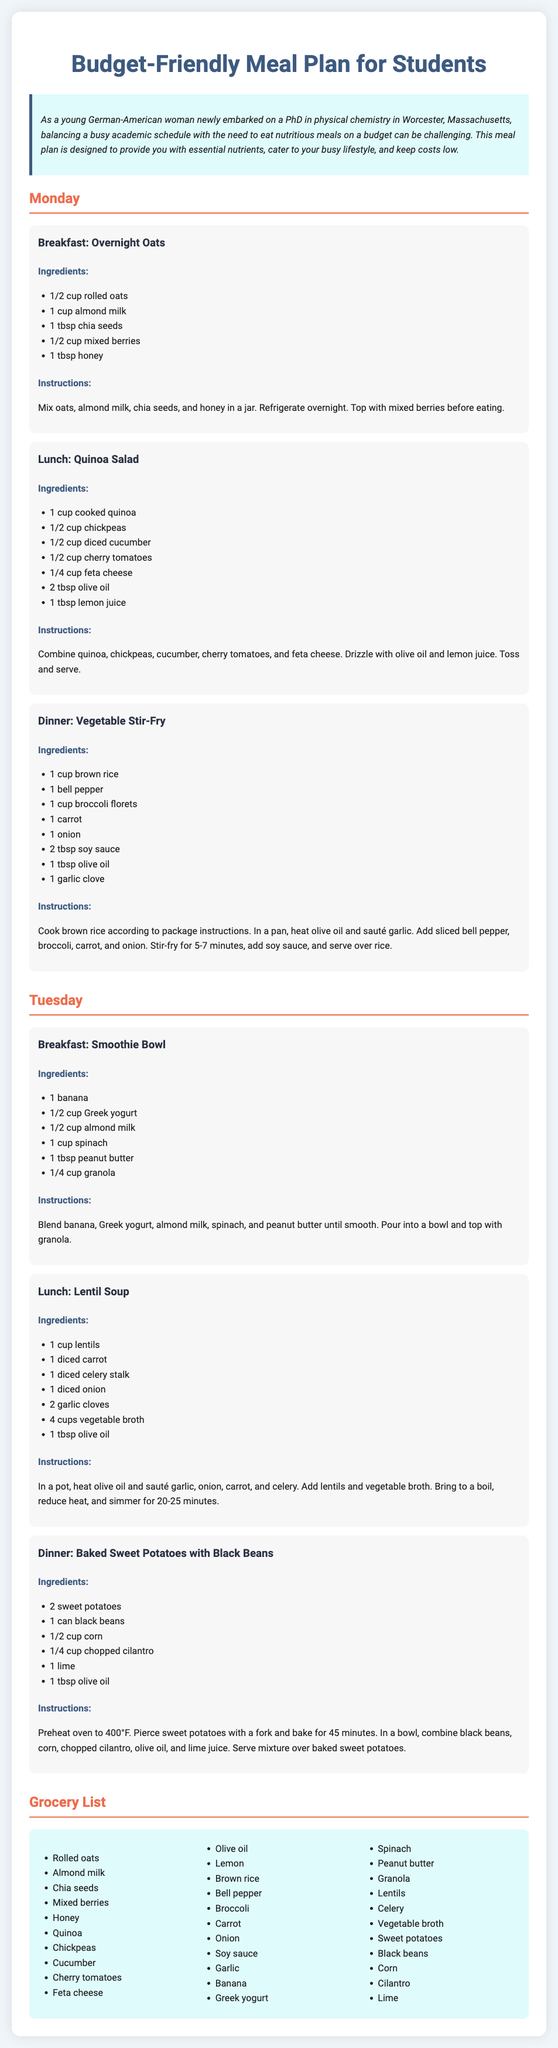What is the main theme of the meal plan? The main theme is about providing nutritious meals while minimizing costs for students.
Answer: Budget-Friendly Meal Plan How many meals are suggested for each day? Each day includes three meals: breakfast, lunch, and dinner.
Answer: Three meals What ingredient is listed for the Saturday breakfast? The ingredient for the breakfast is rolled oats.
Answer: Rolled oats Which vegetable is included in the Vegetable Stir-Fry dinner? The vegetable is broccoli florets.
Answer: Broccoli florets What is the cooking time for lentil soup? The cooking time for lentil soup is 20-25 minutes.
Answer: 20-25 minutes What fruit is used in the Smoothie Bowl? The fruit used is banana.
Answer: Banana How is the Sweet Potatoes with Black Beans dish prepared? The dish is made by baking sweet potatoes and combining with black beans and corn.
Answer: Baking sweet potatoes How many cups of vegetable broth are listed in the Lentil Soup ingredients? The amount of vegetable broth listed is four cups.
Answer: Four cups What dairy product is included in the Smoothie Bowl? The dairy product included is Greek yogurt.
Answer: Greek yogurt 